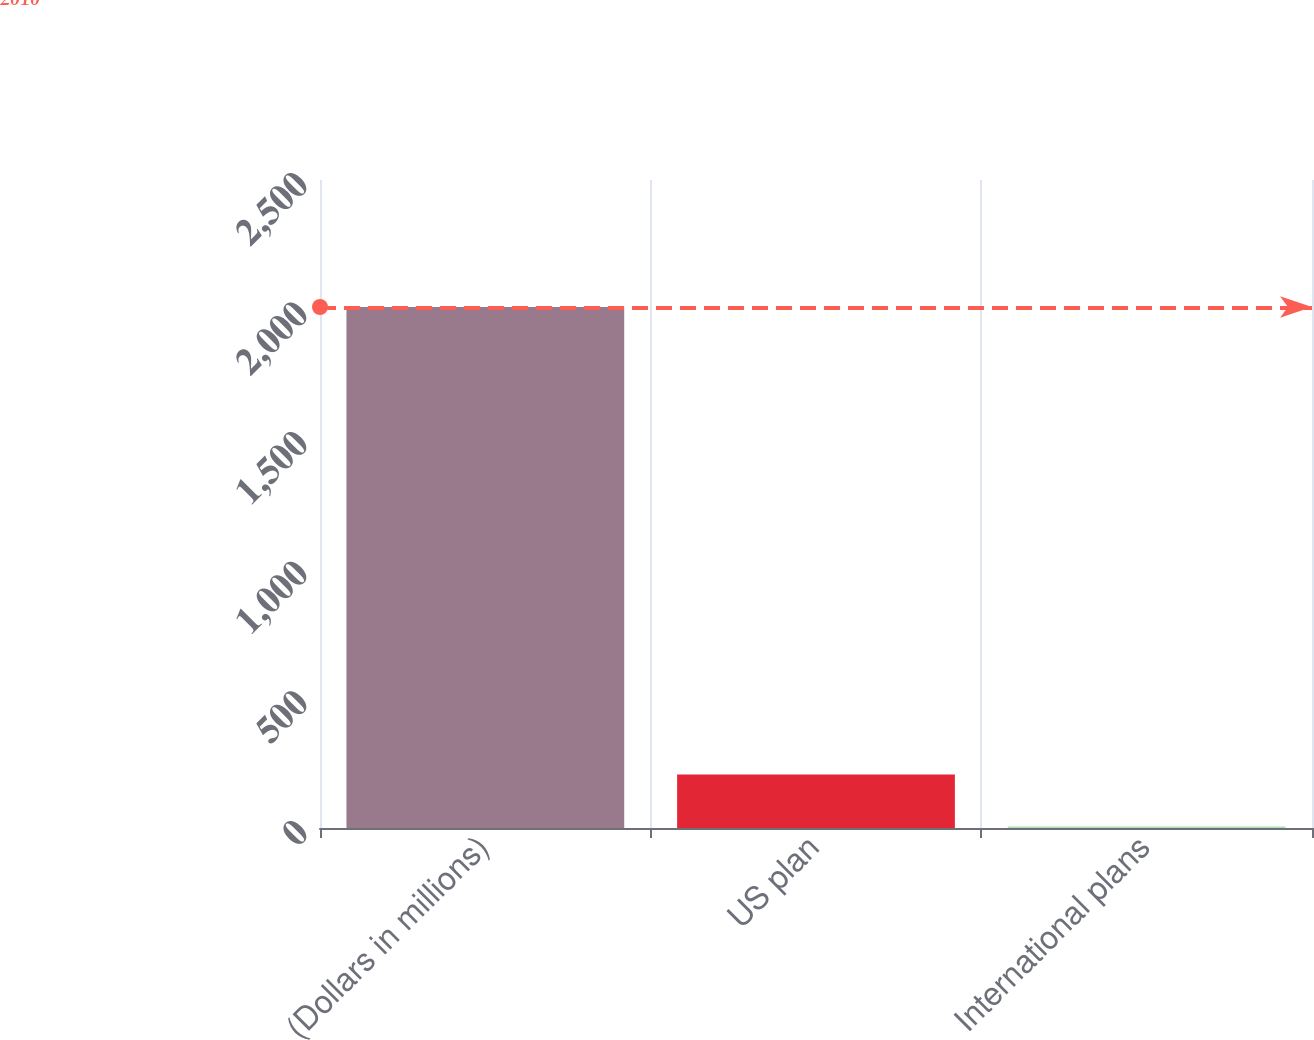Convert chart to OTSL. <chart><loc_0><loc_0><loc_500><loc_500><bar_chart><fcel>(Dollars in millions)<fcel>US plan<fcel>International plans<nl><fcel>2010<fcel>206.4<fcel>6<nl></chart> 